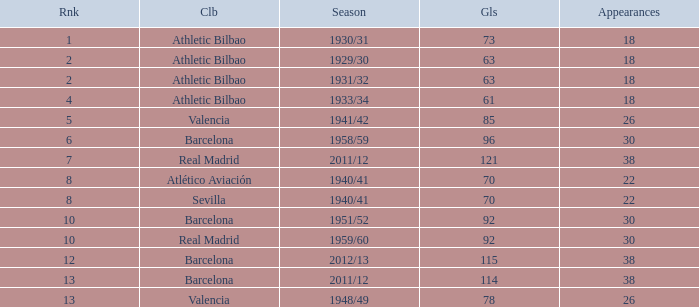What season was Barcelona ranked higher than 12, had more than 96 goals and had more than 26 apps? 2011/12. 